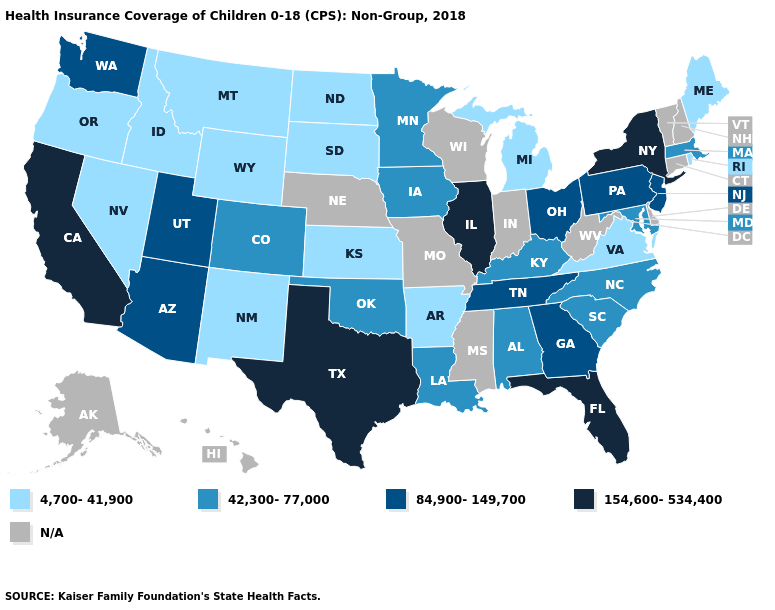Name the states that have a value in the range 42,300-77,000?
Be succinct. Alabama, Colorado, Iowa, Kentucky, Louisiana, Maryland, Massachusetts, Minnesota, North Carolina, Oklahoma, South Carolina. What is the lowest value in the USA?
Give a very brief answer. 4,700-41,900. What is the lowest value in the USA?
Write a very short answer. 4,700-41,900. Does the map have missing data?
Short answer required. Yes. Name the states that have a value in the range 4,700-41,900?
Concise answer only. Arkansas, Idaho, Kansas, Maine, Michigan, Montana, Nevada, New Mexico, North Dakota, Oregon, Rhode Island, South Dakota, Virginia, Wyoming. Which states have the lowest value in the USA?
Quick response, please. Arkansas, Idaho, Kansas, Maine, Michigan, Montana, Nevada, New Mexico, North Dakota, Oregon, Rhode Island, South Dakota, Virginia, Wyoming. Does Kansas have the highest value in the USA?
Give a very brief answer. No. Among the states that border New Hampshire , does Maine have the lowest value?
Write a very short answer. Yes. Which states have the lowest value in the West?
Write a very short answer. Idaho, Montana, Nevada, New Mexico, Oregon, Wyoming. What is the value of Georgia?
Give a very brief answer. 84,900-149,700. What is the lowest value in the Northeast?
Keep it brief. 4,700-41,900. Name the states that have a value in the range 4,700-41,900?
Quick response, please. Arkansas, Idaho, Kansas, Maine, Michigan, Montana, Nevada, New Mexico, North Dakota, Oregon, Rhode Island, South Dakota, Virginia, Wyoming. How many symbols are there in the legend?
Keep it brief. 5. What is the value of Pennsylvania?
Be succinct. 84,900-149,700. 